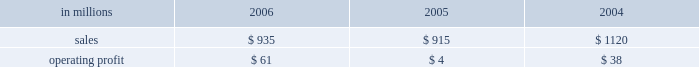Will no longer be significant contributors to business operating results , while expenses should also decline significantly reflecting the reduced level of operations .
Operating earnings will primarily consist of retail forestland and real estate sales of remaining acreage .
Specialty businesses and other the specialty businesses and other segment includes the results of the arizona chemical business and certain divested businesses whose results are included in this segment for periods prior to their sale or closure .
This segment 2019s 2006 net sales increased 2% ( 2 % ) from 2005 , but declined 17% ( 17 % ) from 2004 .
Operating profits in 2006 were up substantially from both 2005 and 2004 .
The decline in sales compared with 2004 principally reflects declining contributions from businesses sold or closed .
Specialty businesses and other in millions 2006 2005 2004 .
Arizona chemical sales were $ 769 million in 2006 , compared with $ 692 million in 2005 and $ 672 million in 2004 .
Sales volumes declined in 2006 compared with 2005 , but average sales price realiza- tions in 2006 were higher in both the united states and europe .
Operating earnings in 2006 were sig- nificantly higher than in 2005 and more than 49% ( 49 % ) higher than in 2004 .
The increase over 2005 reflects the impact of the higher average sales price realiza- tions and lower manufacturing costs , partially offset by higher prices for crude tall oil ( cto ) .
Earnings for 2005 also included a $ 13 million charge related to a plant shutdown in norway .
Other businesses in this operating segment include operations that have been sold , closed or held for sale , primarily the polyrey business in france and , in prior years , the european distribution business .
Sales for these businesses were approximately $ 166 million in 2006 , compared with $ 223 million in 2005 and $ 448 million in 2004 .
In december 2006 , the company entered into a definitive agreement to sell the arizona chemical business , expected to close in the first quarter of liquidity and capital resources overview a major factor in international paper 2019s liquidity and capital resource planning is its generation of operat- ing cash flow , which is highly sensitive to changes in the pricing and demand for our major products .
While changes in key cash operating costs , such as energy and raw material costs , do have an effect on operating cash generation , we believe that our strong focus on cost controls has improved our cash flow generation over an operating cycle .
As part of the continuing focus on improving our return on investment , we have focused our capital spending on improving our key paper and packaging businesses both globally and in north america .
Spending levels have been kept below the level of depreciation and amortization charges for each of the last three years , and we anticipate spending will again be slightly below depreciation and amor- tization in 2007 .
Financing activities in 2006 have been focused on the transformation plan objective of strengthening the balance sheet through repayment of debt , resulting in a net reduction in 2006 of $ 5.2 billion following a $ 1.7 billion net reduction in 2005 .
Additionally , we made a $ 1.0 billion voluntary cash contribution to our u.s .
Qualified pension plan in december 2006 to begin satisfying projected long-term funding requirements and to lower future pension expense .
Our liquidity position continues to be strong , with approximately $ 3.0 billion of committed liquidity to cover future short-term cash flow requirements not met by operating cash flows .
Management believes it is important for interna- tional paper to maintain an investment-grade credit rating to facilitate access to capital markets on favorable terms .
At december 31 , 2006 , the com- pany held long-term credit ratings of bbb ( stable outlook ) and baa3 ( stable outlook ) from standard & poor 2019s and moody 2019s investor services , respectively .
Cash provided by operations cash provided by continuing operations totaled $ 1.0 billion for 2006 , compared with $ 1.2 billion for 2005 and $ 1.7 billion in 2004 .
The 2006 amount is net of a $ 1.0 billion voluntary cash pension plan contribution made in the fourth quarter of 2006 .
The major components of cash provided by continuing oper- ations are earnings from continuing operations .
In 2006 what percentage of specialty businesses sales are from arizona chemical sales? 
Computations: (769 / 935)
Answer: 0.82246. Will no longer be significant contributors to business operating results , while expenses should also decline significantly reflecting the reduced level of operations .
Operating earnings will primarily consist of retail forestland and real estate sales of remaining acreage .
Specialty businesses and other the specialty businesses and other segment includes the results of the arizona chemical business and certain divested businesses whose results are included in this segment for periods prior to their sale or closure .
This segment 2019s 2006 net sales increased 2% ( 2 % ) from 2005 , but declined 17% ( 17 % ) from 2004 .
Operating profits in 2006 were up substantially from both 2005 and 2004 .
The decline in sales compared with 2004 principally reflects declining contributions from businesses sold or closed .
Specialty businesses and other in millions 2006 2005 2004 .
Arizona chemical sales were $ 769 million in 2006 , compared with $ 692 million in 2005 and $ 672 million in 2004 .
Sales volumes declined in 2006 compared with 2005 , but average sales price realiza- tions in 2006 were higher in both the united states and europe .
Operating earnings in 2006 were sig- nificantly higher than in 2005 and more than 49% ( 49 % ) higher than in 2004 .
The increase over 2005 reflects the impact of the higher average sales price realiza- tions and lower manufacturing costs , partially offset by higher prices for crude tall oil ( cto ) .
Earnings for 2005 also included a $ 13 million charge related to a plant shutdown in norway .
Other businesses in this operating segment include operations that have been sold , closed or held for sale , primarily the polyrey business in france and , in prior years , the european distribution business .
Sales for these businesses were approximately $ 166 million in 2006 , compared with $ 223 million in 2005 and $ 448 million in 2004 .
In december 2006 , the company entered into a definitive agreement to sell the arizona chemical business , expected to close in the first quarter of liquidity and capital resources overview a major factor in international paper 2019s liquidity and capital resource planning is its generation of operat- ing cash flow , which is highly sensitive to changes in the pricing and demand for our major products .
While changes in key cash operating costs , such as energy and raw material costs , do have an effect on operating cash generation , we believe that our strong focus on cost controls has improved our cash flow generation over an operating cycle .
As part of the continuing focus on improving our return on investment , we have focused our capital spending on improving our key paper and packaging businesses both globally and in north america .
Spending levels have been kept below the level of depreciation and amortization charges for each of the last three years , and we anticipate spending will again be slightly below depreciation and amor- tization in 2007 .
Financing activities in 2006 have been focused on the transformation plan objective of strengthening the balance sheet through repayment of debt , resulting in a net reduction in 2006 of $ 5.2 billion following a $ 1.7 billion net reduction in 2005 .
Additionally , we made a $ 1.0 billion voluntary cash contribution to our u.s .
Qualified pension plan in december 2006 to begin satisfying projected long-term funding requirements and to lower future pension expense .
Our liquidity position continues to be strong , with approximately $ 3.0 billion of committed liquidity to cover future short-term cash flow requirements not met by operating cash flows .
Management believes it is important for interna- tional paper to maintain an investment-grade credit rating to facilitate access to capital markets on favorable terms .
At december 31 , 2006 , the com- pany held long-term credit ratings of bbb ( stable outlook ) and baa3 ( stable outlook ) from standard & poor 2019s and moody 2019s investor services , respectively .
Cash provided by operations cash provided by continuing operations totaled $ 1.0 billion for 2006 , compared with $ 1.2 billion for 2005 and $ 1.7 billion in 2004 .
The 2006 amount is net of a $ 1.0 billion voluntary cash pension plan contribution made in the fourth quarter of 2006 .
The major components of cash provided by continuing oper- ations are earnings from continuing operations .
In 2005 what percentage of specialty businesses sales are from arizona chemical sales? 
Computations: (692 / 915)
Answer: 0.75628. Will no longer be significant contributors to business operating results , while expenses should also decline significantly reflecting the reduced level of operations .
Operating earnings will primarily consist of retail forestland and real estate sales of remaining acreage .
Specialty businesses and other the specialty businesses and other segment includes the results of the arizona chemical business and certain divested businesses whose results are included in this segment for periods prior to their sale or closure .
This segment 2019s 2006 net sales increased 2% ( 2 % ) from 2005 , but declined 17% ( 17 % ) from 2004 .
Operating profits in 2006 were up substantially from both 2005 and 2004 .
The decline in sales compared with 2004 principally reflects declining contributions from businesses sold or closed .
Specialty businesses and other in millions 2006 2005 2004 .
Arizona chemical sales were $ 769 million in 2006 , compared with $ 692 million in 2005 and $ 672 million in 2004 .
Sales volumes declined in 2006 compared with 2005 , but average sales price realiza- tions in 2006 were higher in both the united states and europe .
Operating earnings in 2006 were sig- nificantly higher than in 2005 and more than 49% ( 49 % ) higher than in 2004 .
The increase over 2005 reflects the impact of the higher average sales price realiza- tions and lower manufacturing costs , partially offset by higher prices for crude tall oil ( cto ) .
Earnings for 2005 also included a $ 13 million charge related to a plant shutdown in norway .
Other businesses in this operating segment include operations that have been sold , closed or held for sale , primarily the polyrey business in france and , in prior years , the european distribution business .
Sales for these businesses were approximately $ 166 million in 2006 , compared with $ 223 million in 2005 and $ 448 million in 2004 .
In december 2006 , the company entered into a definitive agreement to sell the arizona chemical business , expected to close in the first quarter of liquidity and capital resources overview a major factor in international paper 2019s liquidity and capital resource planning is its generation of operat- ing cash flow , which is highly sensitive to changes in the pricing and demand for our major products .
While changes in key cash operating costs , such as energy and raw material costs , do have an effect on operating cash generation , we believe that our strong focus on cost controls has improved our cash flow generation over an operating cycle .
As part of the continuing focus on improving our return on investment , we have focused our capital spending on improving our key paper and packaging businesses both globally and in north america .
Spending levels have been kept below the level of depreciation and amortization charges for each of the last three years , and we anticipate spending will again be slightly below depreciation and amor- tization in 2007 .
Financing activities in 2006 have been focused on the transformation plan objective of strengthening the balance sheet through repayment of debt , resulting in a net reduction in 2006 of $ 5.2 billion following a $ 1.7 billion net reduction in 2005 .
Additionally , we made a $ 1.0 billion voluntary cash contribution to our u.s .
Qualified pension plan in december 2006 to begin satisfying projected long-term funding requirements and to lower future pension expense .
Our liquidity position continues to be strong , with approximately $ 3.0 billion of committed liquidity to cover future short-term cash flow requirements not met by operating cash flows .
Management believes it is important for interna- tional paper to maintain an investment-grade credit rating to facilitate access to capital markets on favorable terms .
At december 31 , 2006 , the com- pany held long-term credit ratings of bbb ( stable outlook ) and baa3 ( stable outlook ) from standard & poor 2019s and moody 2019s investor services , respectively .
Cash provided by operations cash provided by continuing operations totaled $ 1.0 billion for 2006 , compared with $ 1.2 billion for 2005 and $ 1.7 billion in 2004 .
The 2006 amount is net of a $ 1.0 billion voluntary cash pension plan contribution made in the fourth quarter of 2006 .
The major components of cash provided by continuing oper- ations are earnings from continuing operations .
What was the specialty businesses and other profit margin in 2004? 
Computations: (38 / 1120)
Answer: 0.03393. 